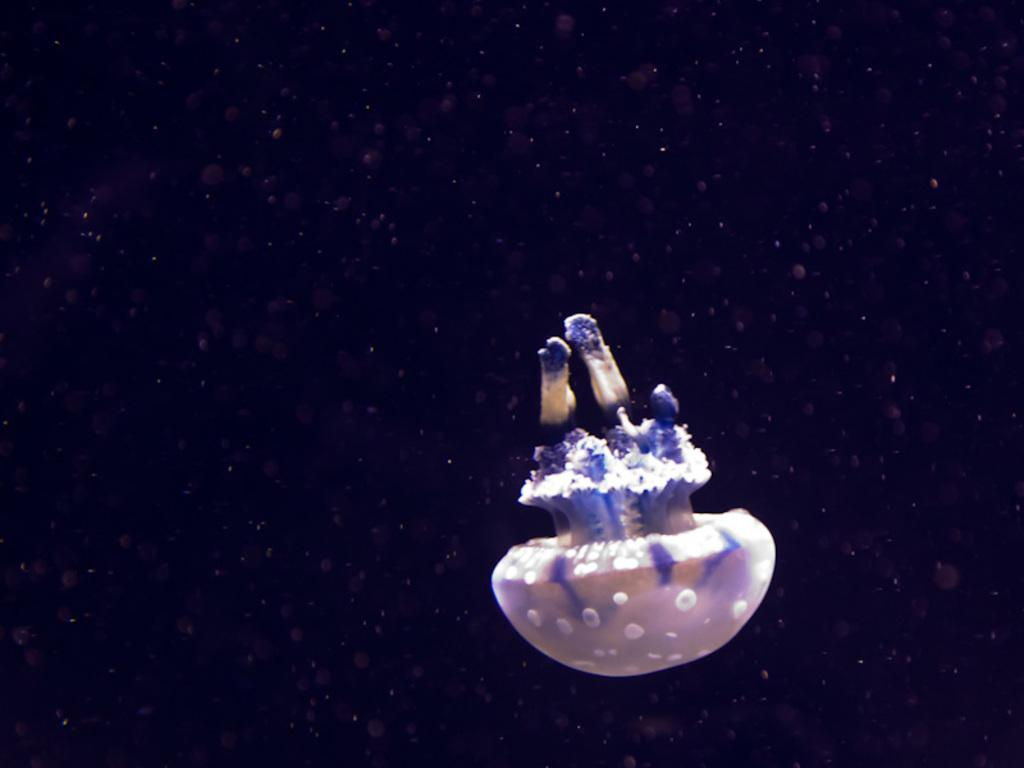What is the main subject of the image? There is an object that appears to be a marine creature in the center of the image. What color is the background of the image? The background of the image is black in color. What type of milk is being poured into the lumber in the image? There is no milk or lumber present in the image. 